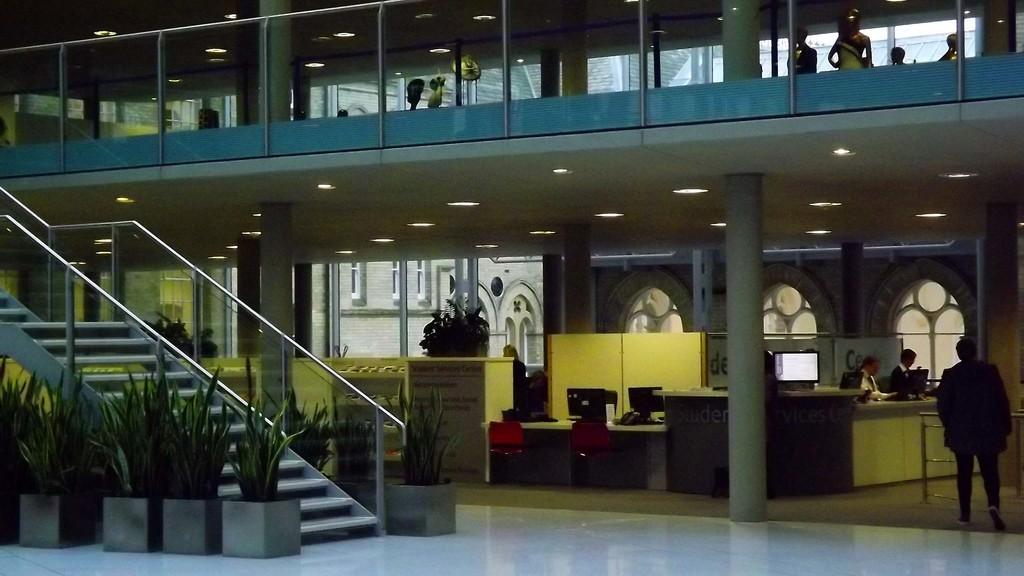Can you describe this image briefly? In this image I can see the inner part of the building. Inside the building I can see the railing, stairs and plants. To the right there are few people with different color dresses. There are screens and laptops on the table. In the top I can see the lights, few more people and the railing. 